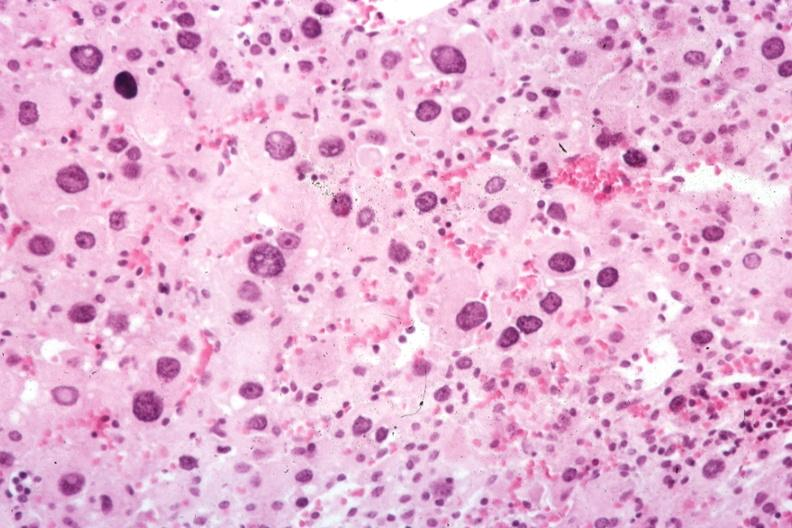s metastatic carcinoma oat cell present?
Answer the question using a single word or phrase. No 